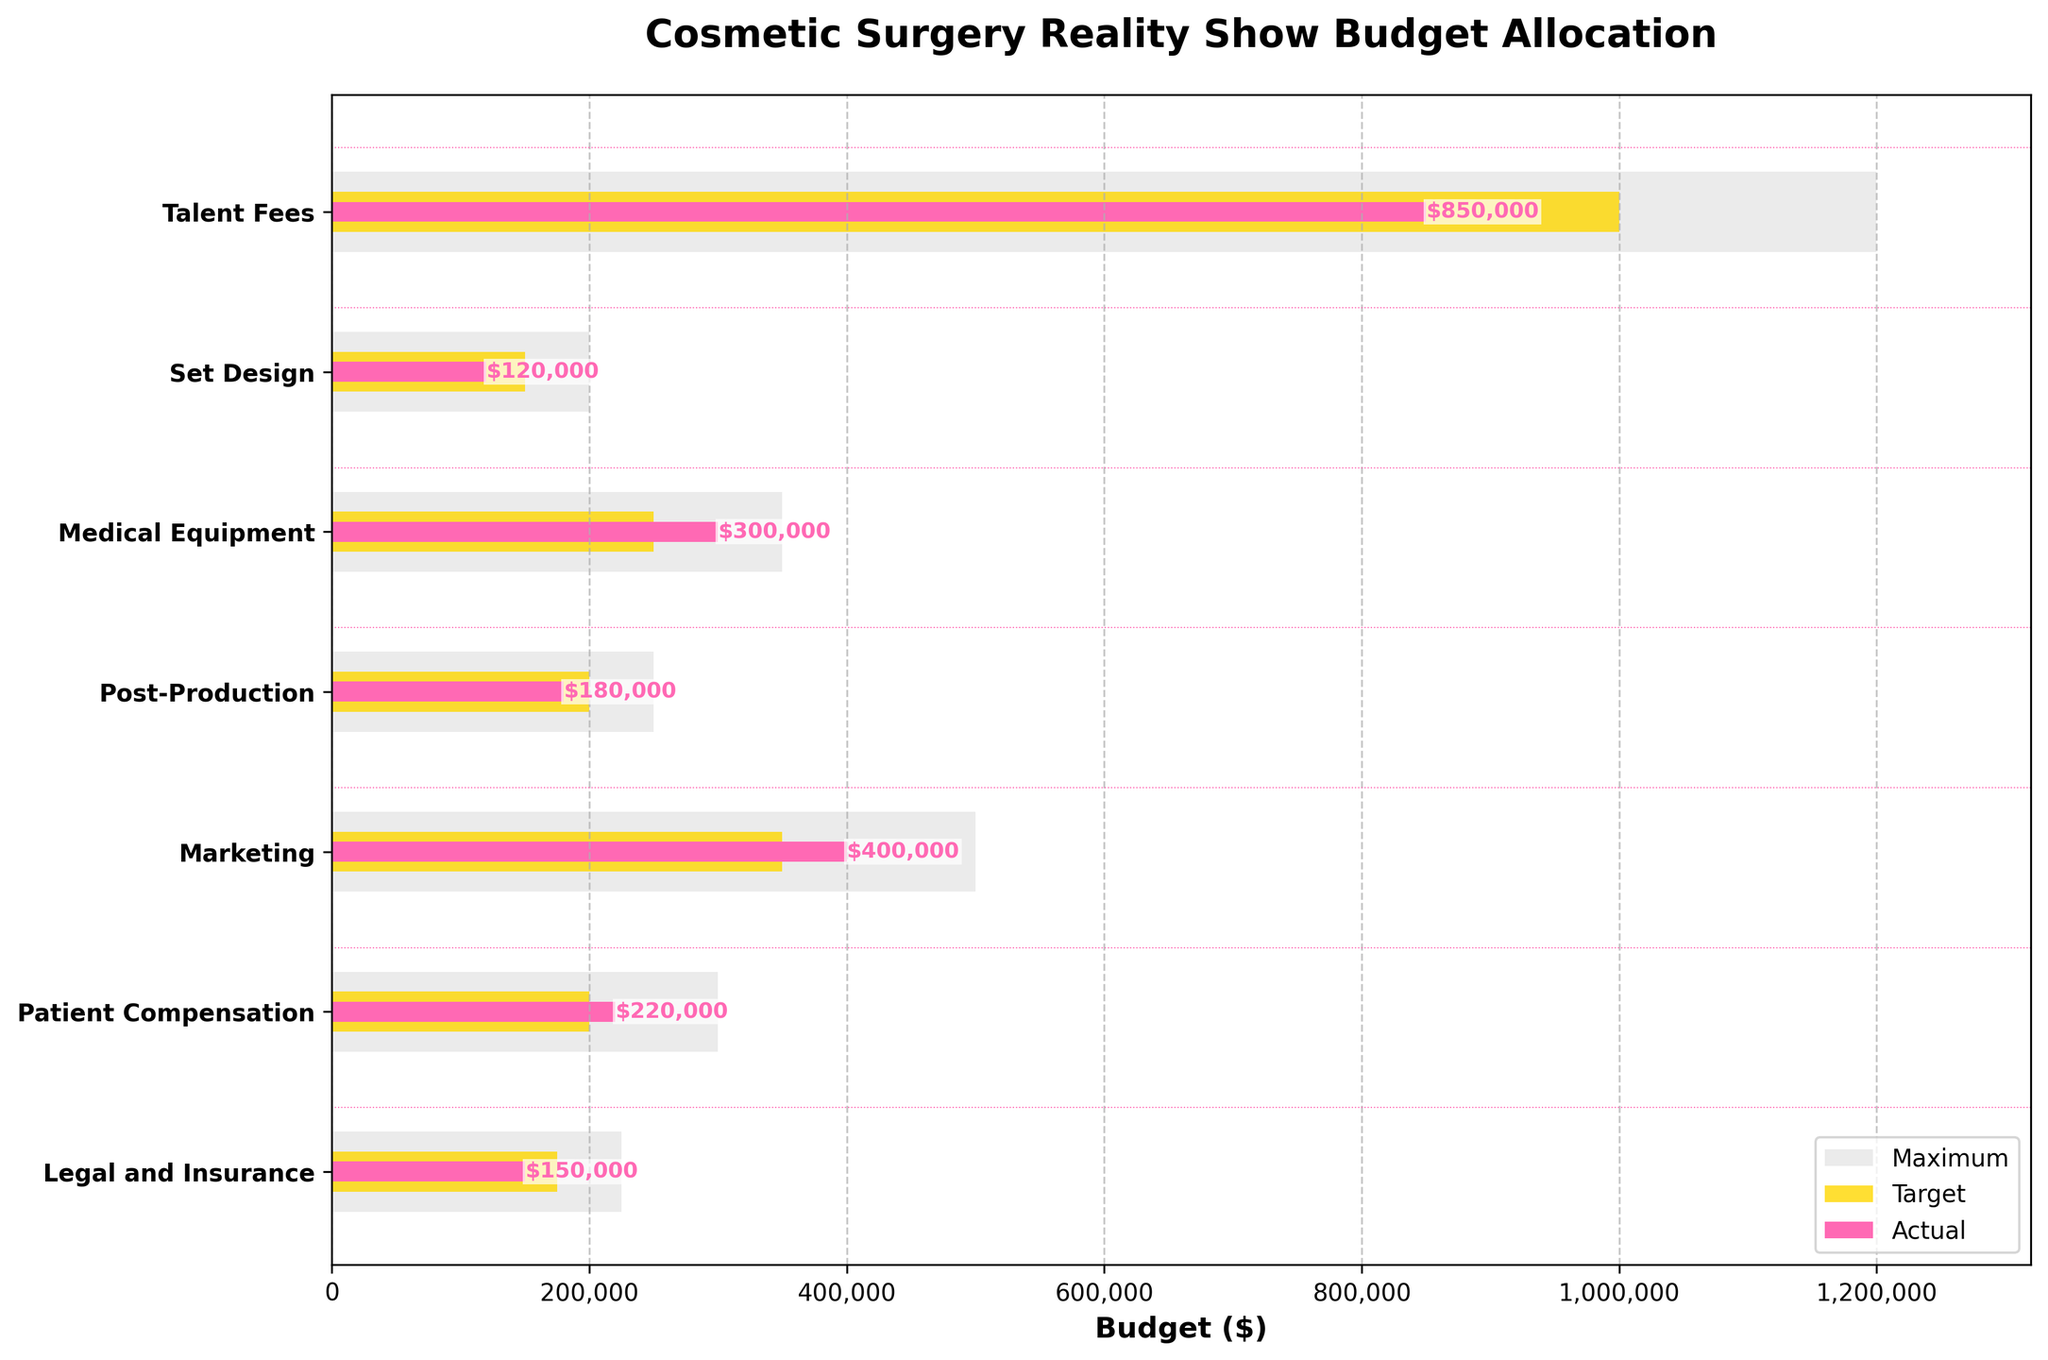What is the title of the plot? The title is usually placed at the top of the chart. Here it is indicated as 'Cosmetic Surgery Reality Show Budget Allocation'.
Answer: Cosmetic Surgery Reality Show Budget Allocation How much was spent on Marketing compared to its target budget? The actual spending for Marketing is shown by the pink bar which is placed at $400,000. The target budget is represented by the golden bar, placed at $350,000.
Answer: $400,000 versus $350,000 Which category exceeded its target the most? To find the category exceeding its target the most, subtract the target from the actual for each category and identify the highest positive difference. Subtracting, Talent Fees: -$150,000, Set Design: -$30,000, Medical Equipment: +$50,000, Post-Production: -$20,000, Marketing: +$50,000, Patient Compensation: +$20,000, Legal and Insurance: -$25,000. Medical Equipment and Marketing both exceed their targets by $50,000.
Answer: Medical Equipment and Marketing For which categories is the actual spending less than the target? Compare the length of the pink bars (actual) with the golden bars (target). Talent Fees, Set Design, Post-Production, and Legal and Insurance show shorter pink bars than golden bars.
Answer: Talent Fees, Set Design, Post-Production, Legal and Insurance What is the total actual spending across all categories? Sum the actual spending amounts: $850,000 (Talent Fees) + $120,000 (Set Design) + $300,000 (Medical Equipment) + $180,000 (Post-Production) + $400,000 (Marketing) + $220,000 (Patient Compensation) + $150,000 (Legal and Insurance). This equals $2,220,000.
Answer: $2,220,000 What color represents the maximum budget in the chart? The maximum budget is represented by the background bars which are colored grey as listed in the description.
Answer: Grey Is any category’s actual spending equal to its target budget? Looking at the placement of the pink bars (actual) in relation to the golden bars (target), none of the categories have their pink bars ending exactly where the golden bars end.
Answer: No What's the difference between the target and actual spending for Legal and Insurance? The target for Legal and Insurance is $175,000 while the actual spending is $150,000. Subtracting them gives $175,000 - $150,000 = $25,000.
Answer: $25,000 List the categories in which the actual expenses are within the budget limits (below the maximum budget). Compare the actual expenses (pink bars) with the maximum budget (background bars). All categories have actual expenses below the maximum budget: Talent Fees ($850,000 < $1,200,000), Set Design ($120,000 < $200,000), Medical Equipment ($300,000 < $350,000), Post-Production ($180,000 < $250,000), Marketing ($400,000 < $500,000), Patient Compensation ($220,000 < $300,000), Legal and Insurance ($150,000 < $225,000).
Answer: All categories 